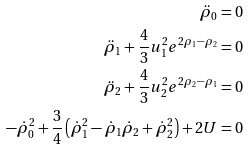Convert formula to latex. <formula><loc_0><loc_0><loc_500><loc_500>\ddot { \rho } _ { 0 } = 0 \\ \ddot { \rho } _ { 1 } + \frac { 4 } { 3 } u _ { 1 } ^ { 2 } e ^ { 2 \rho _ { 1 } - \rho _ { 2 } } = 0 \\ \ddot { \rho } _ { 2 } + \frac { 4 } { 3 } u _ { 2 } ^ { 2 } e ^ { 2 \rho _ { 2 } - \rho _ { 1 } } = 0 \\ - \dot { \rho } _ { 0 } ^ { 2 } + \frac { 3 } { 4 } \left ( \dot { \rho } _ { 1 } ^ { 2 } - \dot { \rho } _ { 1 } \dot { \rho } _ { 2 } + \dot { \rho } _ { 2 } ^ { 2 } \right ) + 2 U = 0</formula> 